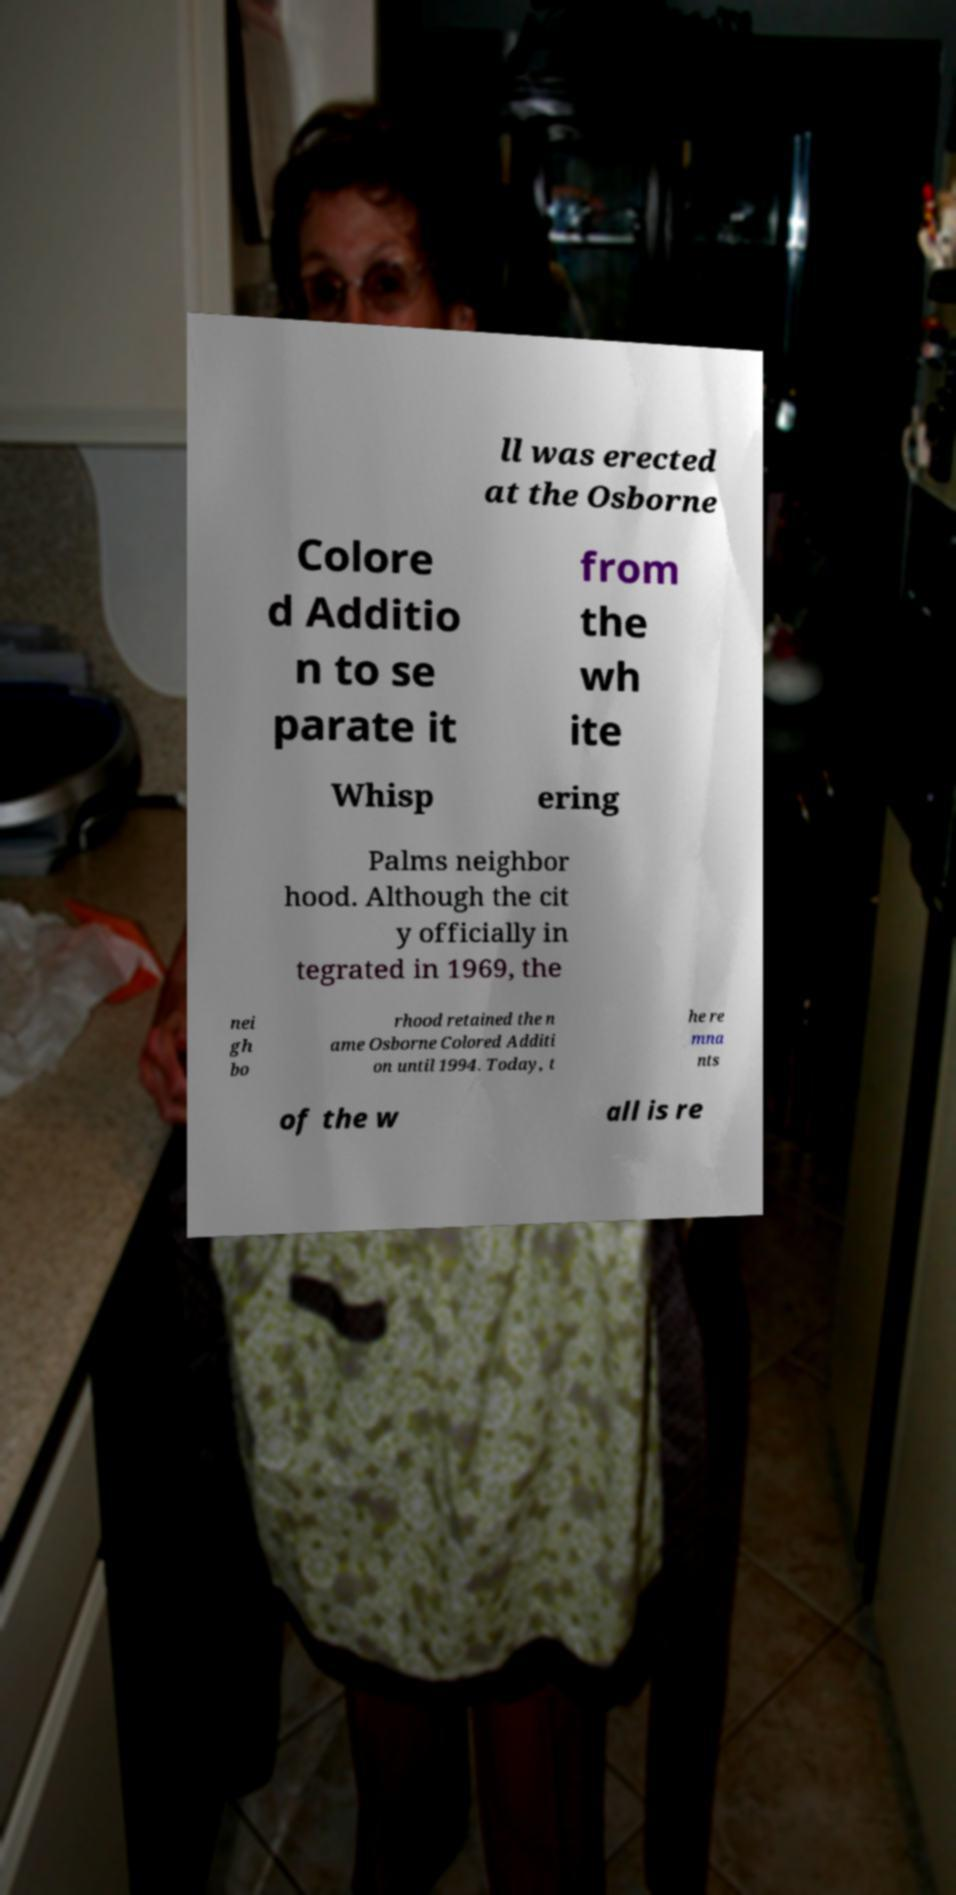Could you extract and type out the text from this image? ll was erected at the Osborne Colore d Additio n to se parate it from the wh ite Whisp ering Palms neighbor hood. Although the cit y officially in tegrated in 1969, the nei gh bo rhood retained the n ame Osborne Colored Additi on until 1994. Today, t he re mna nts of the w all is re 